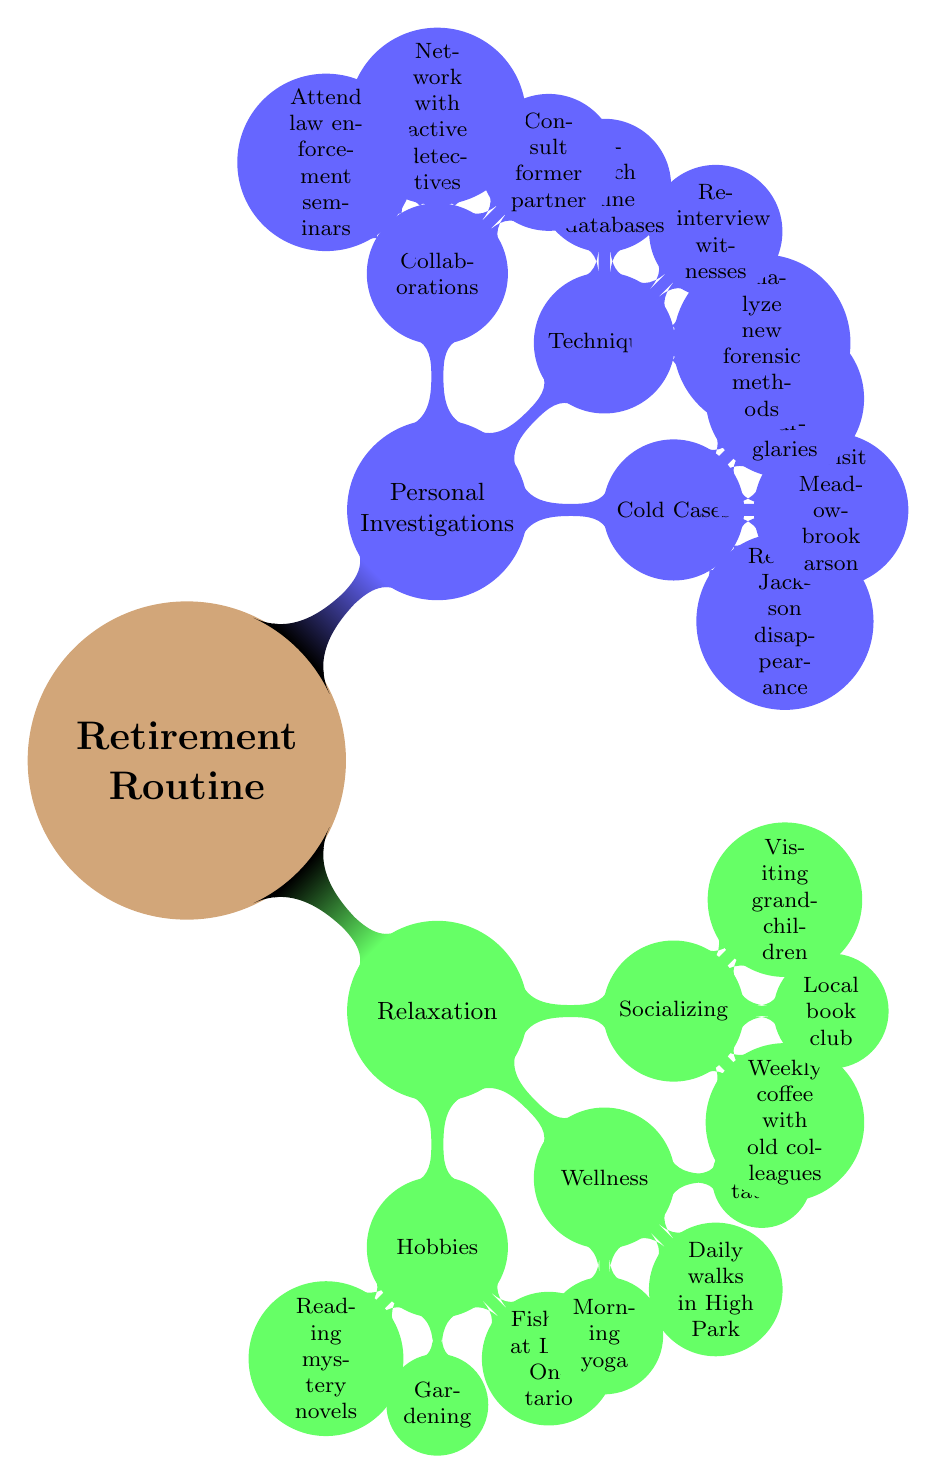What are the main branches of the mind map? The mind map has two main branches labeled "Relaxation" and "Personal Investigations". These branches divide the overall topic of "Retirement Routine" into distinct categories.
Answer: Relaxation, Personal Investigations How many hobbies are listed under Relaxation? Under the "Hobbies" node in the "Relaxation" branch, there are three specific activities mentioned: "Reading mystery novels", "Gardening", and "Fishing at Lake Ontario". Hence, the count is obtained directly from this node.
Answer: 3 What is one technique mentioned for Personal Investigations? The "Techniques" node lists three methods, one of which is "Analyze new forensic methods". This is one example selected from the options provided under this node.
Answer: Analyze new forensic methods Which wellness activity involves physical movement? Under the "Wellness" section of the "Relaxation" branch, the activities "Morning yoga", "Daily walks in High Park", and "Meditation" are listed. Among these, "Daily walks in High Park" involves physical movement, thereby qualifying as such.
Answer: Daily walks in High Park Which cold case is mentioned first under Personal Investigations? In the "Cold Cases" node of the "Personal Investigations" branch, the first listed item is "Review files on the Jackson disappearance", which is positioned at the top of the list and highlights the primary focus of attention.
Answer: Review files on the Jackson disappearance How are the categories of "Hobbies" and "Techniques" related to Retirement Routine? Both "Hobbies" under "Relaxation" and "Techniques" under "Personal Investigations" are subcategories of the overarching theme "Retirement Routine". They represent different aspects of how a retired individual balances leisure and personal inquiry.
Answer: They are subcategories of Retirement Routine What is the total number of items listed in the "Socializing" section? The "Socializing" node contains three individual activities: "Weekly coffee with old colleagues", "Local book club", and "Visiting grandchildren". Therefore, the total number of items here is directly obtained from counting these three activities.
Answer: 3 What type of meetings is included in Collaborations? The "Collaborations" node mentions three specific actions, one of which is "Attend law enforcement seminars". This activity implies the nature of meetings related to learning and networking within the law enforcement community.
Answer: Attend law enforcement seminars What aspect does the "Fishing at Lake Ontario" belong to? The phrase "Fishing at Lake Ontario" is categorized under the "Hobbies" node in the "Relaxation" branch, clearly associating it with leisure activities pursued during retirement.
Answer: Hobbies 